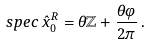Convert formula to latex. <formula><loc_0><loc_0><loc_500><loc_500>s p e c \, \hat { x } _ { 0 } ^ { R } = \theta \mathbb { Z } + \frac { \theta \varphi } { 2 \pi } \, .</formula> 